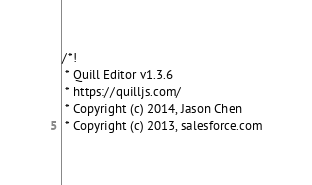<code> <loc_0><loc_0><loc_500><loc_500><_CSS_>/*!
 * Quill Editor v1.3.6
 * https://quilljs.com/
 * Copyright (c) 2014, Jason Chen
 * Copyright (c) 2013, salesforce.com</code> 